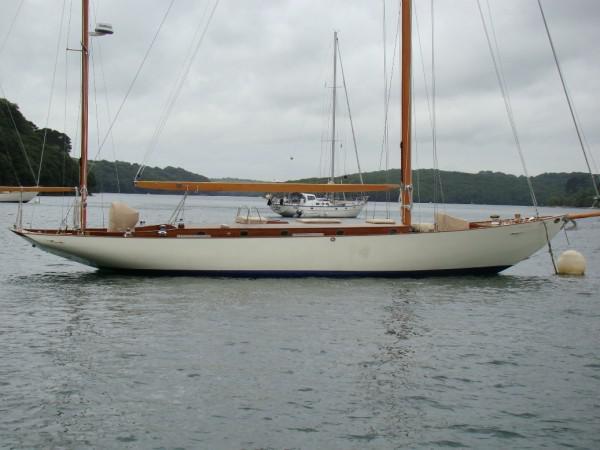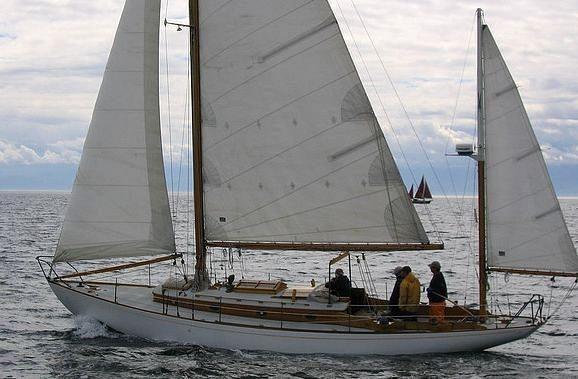The first image is the image on the left, the second image is the image on the right. Analyze the images presented: Is the assertion "A second boat is visible behind the closer boat in the image on the left." valid? Answer yes or no. Yes. The first image is the image on the left, the second image is the image on the right. For the images displayed, is the sentence "At least one white sail is up." factually correct? Answer yes or no. Yes. 